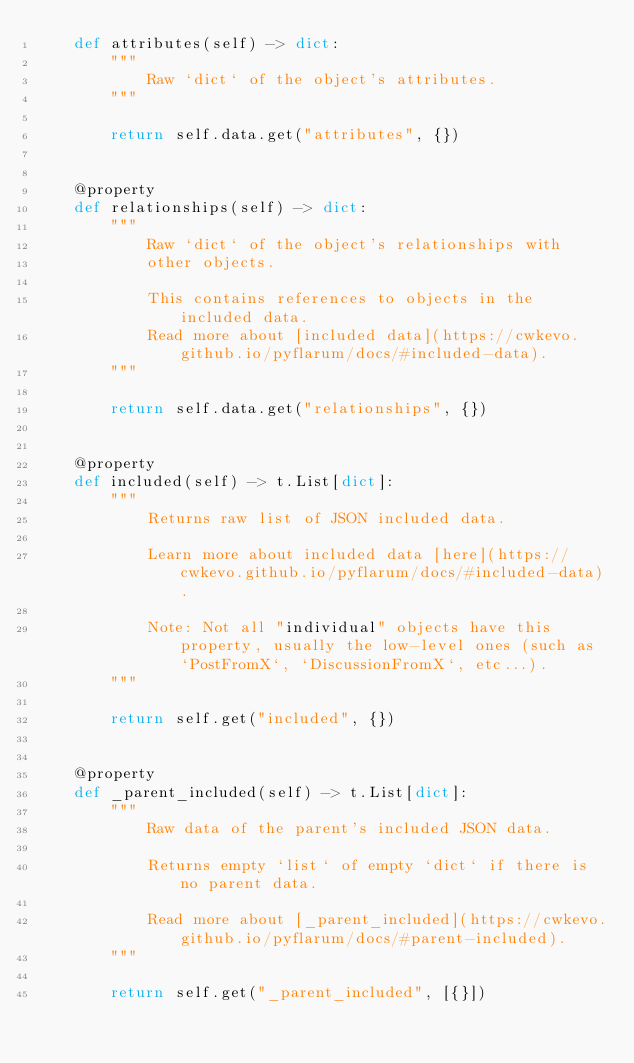<code> <loc_0><loc_0><loc_500><loc_500><_Python_>    def attributes(self) -> dict:
        """
            Raw `dict` of the object's attributes.
        """

        return self.data.get("attributes", {})


    @property
    def relationships(self) -> dict:
        """
            Raw `dict` of the object's relationships with
            other objects.

            This contains references to objects in the included data.
            Read more about [included data](https://cwkevo.github.io/pyflarum/docs/#included-data).
        """

        return self.data.get("relationships", {})


    @property
    def included(self) -> t.List[dict]:
        """
            Returns raw list of JSON included data.

            Learn more about included data [here](https://cwkevo.github.io/pyflarum/docs/#included-data).

            Note: Not all "individual" objects have this property, usually the low-level ones (such as `PostFromX`, `DiscussionFromX`, etc...).
        """

        return self.get("included", {})


    @property
    def _parent_included(self) -> t.List[dict]:
        """
            Raw data of the parent's included JSON data.

            Returns empty `list` of empty `dict` if there is no parent data.

            Read more about [_parent_included](https://cwkevo.github.io/pyflarum/docs/#parent-included).
        """

        return self.get("_parent_included", [{}])
</code> 